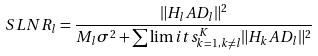<formula> <loc_0><loc_0><loc_500><loc_500>S L N R _ { l } = \frac { \| H _ { l } A D _ { l } \| ^ { 2 } } { M _ { l } \sigma ^ { 2 } + \sum \lim i t s _ { k = 1 , k \neq l } ^ { K } \| H _ { k } A D _ { l } \| ^ { 2 } }</formula> 